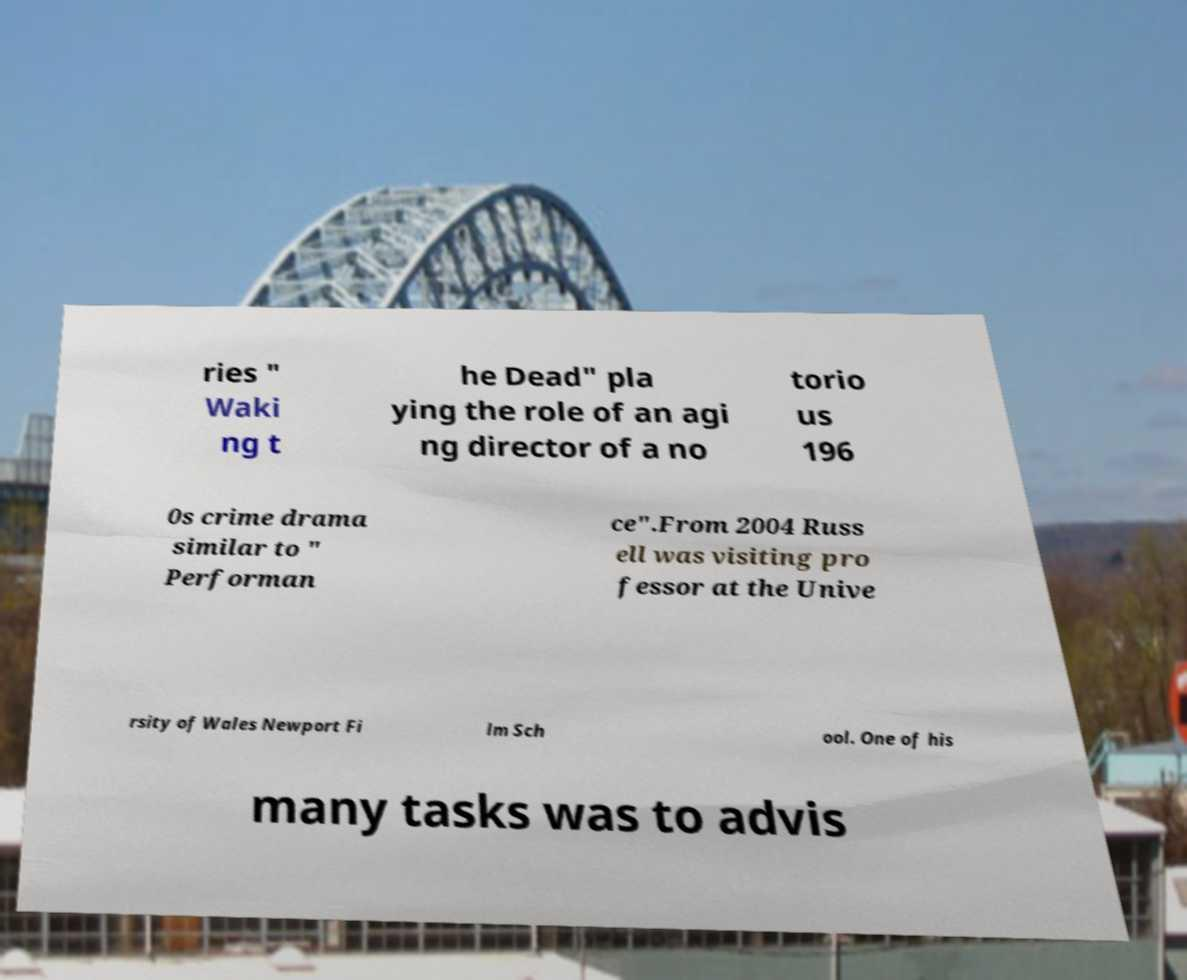Can you read and provide the text displayed in the image?This photo seems to have some interesting text. Can you extract and type it out for me? ries " Waki ng t he Dead" pla ying the role of an agi ng director of a no torio us 196 0s crime drama similar to " Performan ce".From 2004 Russ ell was visiting pro fessor at the Unive rsity of Wales Newport Fi lm Sch ool. One of his many tasks was to advis 